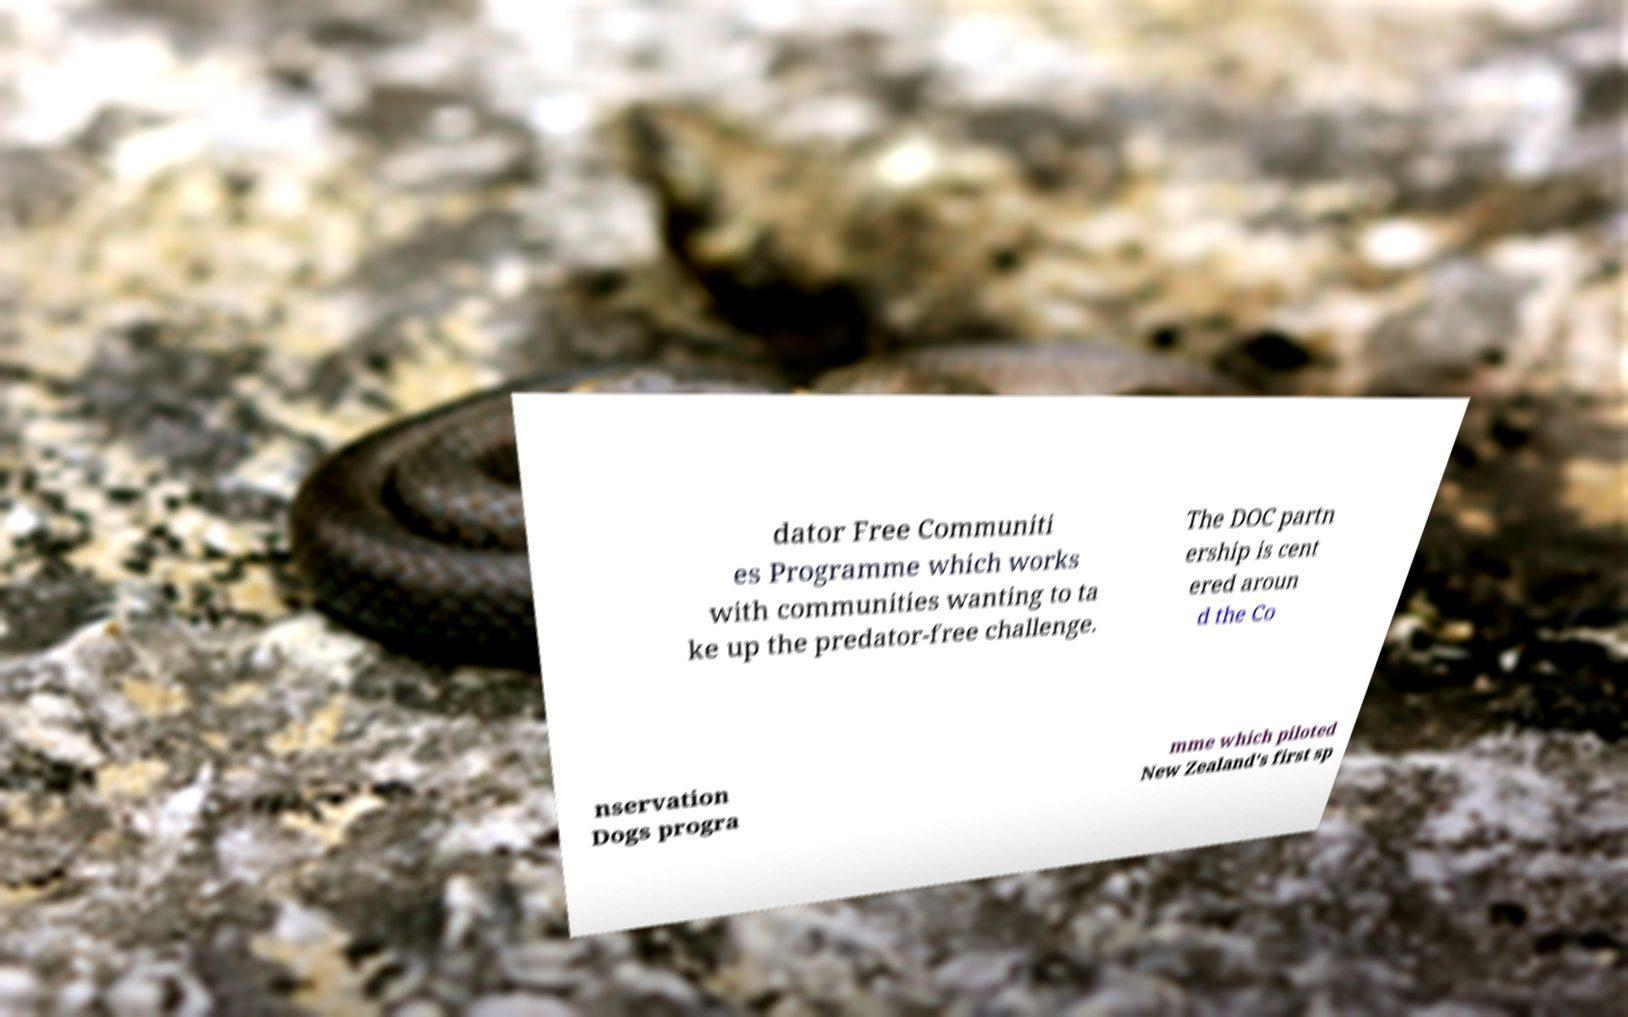Can you accurately transcribe the text from the provided image for me? dator Free Communiti es Programme which works with communities wanting to ta ke up the predator-free challenge. The DOC partn ership is cent ered aroun d the Co nservation Dogs progra mme which piloted New Zealand's first sp 